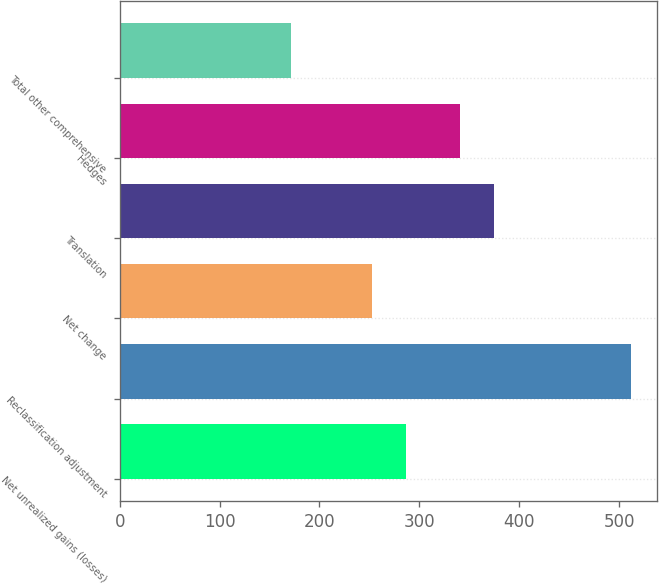<chart> <loc_0><loc_0><loc_500><loc_500><bar_chart><fcel>Net unrealized gains (losses)<fcel>Reclassification adjustment<fcel>Net change<fcel>Translation<fcel>Hedges<fcel>Total other comprehensive<nl><fcel>287.1<fcel>512<fcel>253<fcel>375.1<fcel>341<fcel>171<nl></chart> 